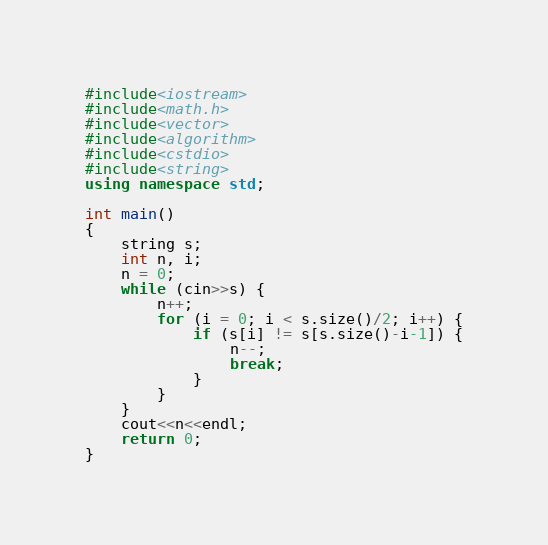Convert code to text. <code><loc_0><loc_0><loc_500><loc_500><_C++_>#include<iostream>
#include<math.h>
#include<vector>
#include<algorithm>
#include<cstdio>
#include<string>
using namespace std;
 
int main()
{
    string s;
    int n, i;
    n = 0;
    while (cin>>s) {
        n++;
        for (i = 0; i < s.size()/2; i++) {
            if (s[i] != s[s.size()-i-1]) {
                n--;
                break;
            }
        }
    }
    cout<<n<<endl;
    return 0;
}
</code> 